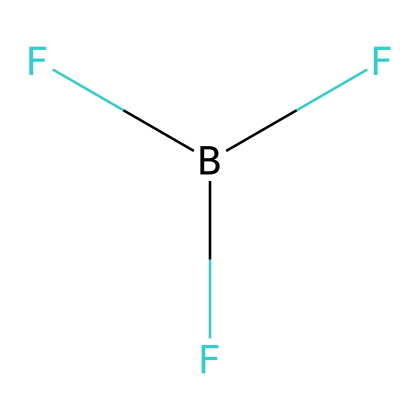What is the number of fluorine atoms in boron trifluoride? The SMILES representation contains three 'F' symbols, indicating three fluorine atoms bonded to one boron atom.
Answer: three What is the central atom in boron trifluoride? The structure shows a 'B' symbol, indicating that boron is the central atom surrounded by fluorine atoms.
Answer: boron What type of bonds are present in boron trifluoride? In the structure, boron forms covalent bonds with each fluorine atom, indicated by their connectivity without any charge symbols.
Answer: covalent bonds How many overall valence electrons are there in boron trifluoride? Boron contributes three valence electrons, and each fluorine contributes seven, totaling 3 + (3 × 7) = 24 valence electrons.
Answer: twenty-four Does boron trifluoride obey the octet rule? Boron has only six electrons around it (three bonds), which does not satisfy the octet rule, making it an exception.
Answer: no What type of compound is boron trifluoride classified as? Based on its composition of boron and fluorine, it is classified as a borane, a type of covalent compound.
Answer: borane 